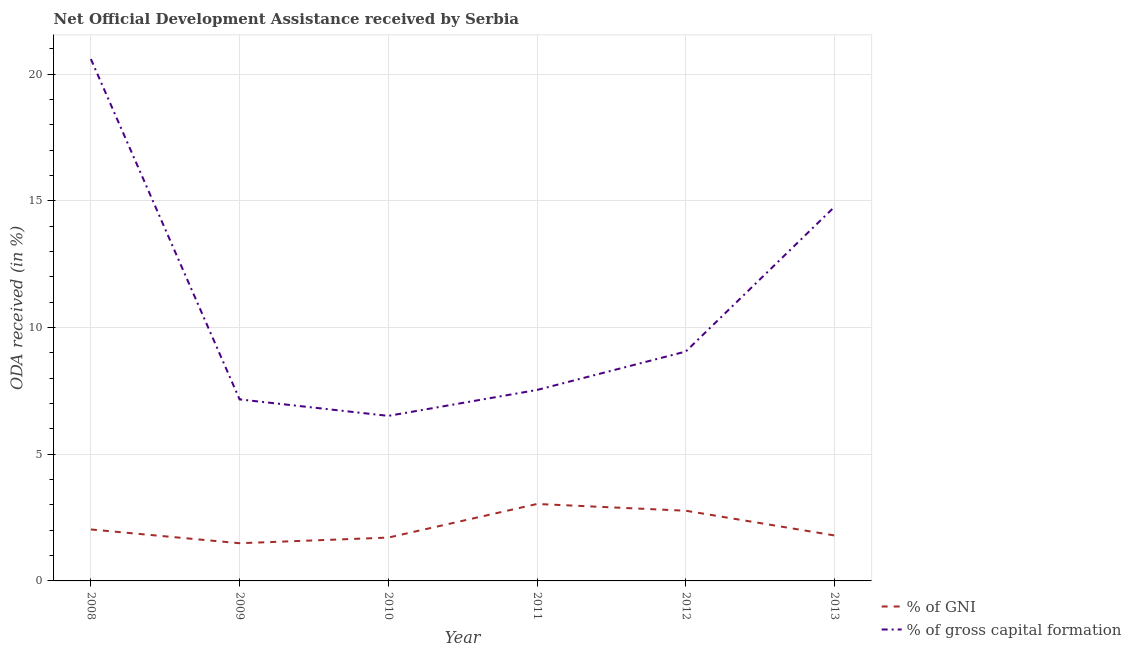How many different coloured lines are there?
Give a very brief answer. 2. What is the oda received as percentage of gross capital formation in 2011?
Ensure brevity in your answer.  7.54. Across all years, what is the maximum oda received as percentage of gni?
Make the answer very short. 3.04. Across all years, what is the minimum oda received as percentage of gni?
Your response must be concise. 1.49. In which year was the oda received as percentage of gni minimum?
Make the answer very short. 2009. What is the total oda received as percentage of gni in the graph?
Ensure brevity in your answer.  12.83. What is the difference between the oda received as percentage of gross capital formation in 2008 and that in 2011?
Provide a succinct answer. 13.06. What is the difference between the oda received as percentage of gross capital formation in 2009 and the oda received as percentage of gni in 2013?
Offer a terse response. 5.37. What is the average oda received as percentage of gross capital formation per year?
Offer a very short reply. 10.94. In the year 2010, what is the difference between the oda received as percentage of gross capital formation and oda received as percentage of gni?
Your response must be concise. 4.8. In how many years, is the oda received as percentage of gni greater than 12 %?
Provide a short and direct response. 0. What is the ratio of the oda received as percentage of gross capital formation in 2008 to that in 2009?
Your answer should be compact. 2.87. What is the difference between the highest and the second highest oda received as percentage of gross capital formation?
Provide a short and direct response. 5.83. What is the difference between the highest and the lowest oda received as percentage of gni?
Your answer should be compact. 1.55. In how many years, is the oda received as percentage of gross capital formation greater than the average oda received as percentage of gross capital formation taken over all years?
Your response must be concise. 2. Is the sum of the oda received as percentage of gross capital formation in 2008 and 2010 greater than the maximum oda received as percentage of gni across all years?
Give a very brief answer. Yes. Is the oda received as percentage of gni strictly greater than the oda received as percentage of gross capital formation over the years?
Offer a terse response. No. Is the oda received as percentage of gross capital formation strictly less than the oda received as percentage of gni over the years?
Keep it short and to the point. No. Are the values on the major ticks of Y-axis written in scientific E-notation?
Provide a succinct answer. No. Where does the legend appear in the graph?
Your response must be concise. Bottom right. How are the legend labels stacked?
Provide a succinct answer. Vertical. What is the title of the graph?
Give a very brief answer. Net Official Development Assistance received by Serbia. Does "Female entrants" appear as one of the legend labels in the graph?
Make the answer very short. No. What is the label or title of the Y-axis?
Keep it short and to the point. ODA received (in %). What is the ODA received (in %) in % of GNI in 2008?
Your answer should be compact. 2.03. What is the ODA received (in %) in % of gross capital formation in 2008?
Your answer should be very brief. 20.6. What is the ODA received (in %) in % of GNI in 2009?
Keep it short and to the point. 1.49. What is the ODA received (in %) of % of gross capital formation in 2009?
Your answer should be very brief. 7.16. What is the ODA received (in %) in % of GNI in 2010?
Make the answer very short. 1.71. What is the ODA received (in %) in % of gross capital formation in 2010?
Ensure brevity in your answer.  6.51. What is the ODA received (in %) in % of GNI in 2011?
Keep it short and to the point. 3.04. What is the ODA received (in %) in % of gross capital formation in 2011?
Give a very brief answer. 7.54. What is the ODA received (in %) in % of GNI in 2012?
Your answer should be very brief. 2.77. What is the ODA received (in %) in % of gross capital formation in 2012?
Make the answer very short. 9.05. What is the ODA received (in %) in % of GNI in 2013?
Give a very brief answer. 1.79. What is the ODA received (in %) of % of gross capital formation in 2013?
Provide a succinct answer. 14.77. Across all years, what is the maximum ODA received (in %) of % of GNI?
Your answer should be compact. 3.04. Across all years, what is the maximum ODA received (in %) of % of gross capital formation?
Your answer should be compact. 20.6. Across all years, what is the minimum ODA received (in %) in % of GNI?
Give a very brief answer. 1.49. Across all years, what is the minimum ODA received (in %) of % of gross capital formation?
Provide a succinct answer. 6.51. What is the total ODA received (in %) in % of GNI in the graph?
Your answer should be compact. 12.83. What is the total ODA received (in %) in % of gross capital formation in the graph?
Keep it short and to the point. 65.63. What is the difference between the ODA received (in %) in % of GNI in 2008 and that in 2009?
Ensure brevity in your answer.  0.54. What is the difference between the ODA received (in %) of % of gross capital formation in 2008 and that in 2009?
Ensure brevity in your answer.  13.43. What is the difference between the ODA received (in %) in % of GNI in 2008 and that in 2010?
Make the answer very short. 0.32. What is the difference between the ODA received (in %) in % of gross capital formation in 2008 and that in 2010?
Offer a terse response. 14.08. What is the difference between the ODA received (in %) of % of GNI in 2008 and that in 2011?
Your response must be concise. -1.01. What is the difference between the ODA received (in %) of % of gross capital formation in 2008 and that in 2011?
Offer a very short reply. 13.06. What is the difference between the ODA received (in %) in % of GNI in 2008 and that in 2012?
Give a very brief answer. -0.74. What is the difference between the ODA received (in %) in % of gross capital formation in 2008 and that in 2012?
Make the answer very short. 11.54. What is the difference between the ODA received (in %) in % of GNI in 2008 and that in 2013?
Provide a short and direct response. 0.24. What is the difference between the ODA received (in %) in % of gross capital formation in 2008 and that in 2013?
Offer a terse response. 5.83. What is the difference between the ODA received (in %) of % of GNI in 2009 and that in 2010?
Keep it short and to the point. -0.22. What is the difference between the ODA received (in %) in % of gross capital formation in 2009 and that in 2010?
Your response must be concise. 0.65. What is the difference between the ODA received (in %) of % of GNI in 2009 and that in 2011?
Make the answer very short. -1.55. What is the difference between the ODA received (in %) in % of gross capital formation in 2009 and that in 2011?
Your response must be concise. -0.37. What is the difference between the ODA received (in %) in % of GNI in 2009 and that in 2012?
Make the answer very short. -1.28. What is the difference between the ODA received (in %) of % of gross capital formation in 2009 and that in 2012?
Provide a succinct answer. -1.89. What is the difference between the ODA received (in %) in % of GNI in 2009 and that in 2013?
Keep it short and to the point. -0.31. What is the difference between the ODA received (in %) in % of gross capital formation in 2009 and that in 2013?
Give a very brief answer. -7.6. What is the difference between the ODA received (in %) in % of GNI in 2010 and that in 2011?
Offer a very short reply. -1.33. What is the difference between the ODA received (in %) of % of gross capital formation in 2010 and that in 2011?
Give a very brief answer. -1.02. What is the difference between the ODA received (in %) of % of GNI in 2010 and that in 2012?
Provide a short and direct response. -1.06. What is the difference between the ODA received (in %) in % of gross capital formation in 2010 and that in 2012?
Give a very brief answer. -2.54. What is the difference between the ODA received (in %) in % of GNI in 2010 and that in 2013?
Give a very brief answer. -0.08. What is the difference between the ODA received (in %) in % of gross capital formation in 2010 and that in 2013?
Your answer should be very brief. -8.25. What is the difference between the ODA received (in %) in % of GNI in 2011 and that in 2012?
Give a very brief answer. 0.27. What is the difference between the ODA received (in %) of % of gross capital formation in 2011 and that in 2012?
Offer a very short reply. -1.52. What is the difference between the ODA received (in %) of % of GNI in 2011 and that in 2013?
Provide a short and direct response. 1.24. What is the difference between the ODA received (in %) in % of gross capital formation in 2011 and that in 2013?
Your answer should be compact. -7.23. What is the difference between the ODA received (in %) of % of GNI in 2012 and that in 2013?
Provide a succinct answer. 0.98. What is the difference between the ODA received (in %) in % of gross capital formation in 2012 and that in 2013?
Your answer should be very brief. -5.71. What is the difference between the ODA received (in %) in % of GNI in 2008 and the ODA received (in %) in % of gross capital formation in 2009?
Keep it short and to the point. -5.13. What is the difference between the ODA received (in %) in % of GNI in 2008 and the ODA received (in %) in % of gross capital formation in 2010?
Your answer should be very brief. -4.48. What is the difference between the ODA received (in %) of % of GNI in 2008 and the ODA received (in %) of % of gross capital formation in 2011?
Ensure brevity in your answer.  -5.51. What is the difference between the ODA received (in %) in % of GNI in 2008 and the ODA received (in %) in % of gross capital formation in 2012?
Give a very brief answer. -7.02. What is the difference between the ODA received (in %) in % of GNI in 2008 and the ODA received (in %) in % of gross capital formation in 2013?
Make the answer very short. -12.73. What is the difference between the ODA received (in %) in % of GNI in 2009 and the ODA received (in %) in % of gross capital formation in 2010?
Offer a very short reply. -5.03. What is the difference between the ODA received (in %) of % of GNI in 2009 and the ODA received (in %) of % of gross capital formation in 2011?
Provide a succinct answer. -6.05. What is the difference between the ODA received (in %) in % of GNI in 2009 and the ODA received (in %) in % of gross capital formation in 2012?
Make the answer very short. -7.57. What is the difference between the ODA received (in %) of % of GNI in 2009 and the ODA received (in %) of % of gross capital formation in 2013?
Make the answer very short. -13.28. What is the difference between the ODA received (in %) in % of GNI in 2010 and the ODA received (in %) in % of gross capital formation in 2011?
Provide a succinct answer. -5.83. What is the difference between the ODA received (in %) in % of GNI in 2010 and the ODA received (in %) in % of gross capital formation in 2012?
Keep it short and to the point. -7.34. What is the difference between the ODA received (in %) in % of GNI in 2010 and the ODA received (in %) in % of gross capital formation in 2013?
Keep it short and to the point. -13.05. What is the difference between the ODA received (in %) in % of GNI in 2011 and the ODA received (in %) in % of gross capital formation in 2012?
Your answer should be compact. -6.02. What is the difference between the ODA received (in %) of % of GNI in 2011 and the ODA received (in %) of % of gross capital formation in 2013?
Offer a very short reply. -11.73. What is the difference between the ODA received (in %) of % of GNI in 2012 and the ODA received (in %) of % of gross capital formation in 2013?
Offer a terse response. -11.99. What is the average ODA received (in %) in % of GNI per year?
Give a very brief answer. 2.14. What is the average ODA received (in %) of % of gross capital formation per year?
Ensure brevity in your answer.  10.94. In the year 2008, what is the difference between the ODA received (in %) in % of GNI and ODA received (in %) in % of gross capital formation?
Your answer should be very brief. -18.57. In the year 2009, what is the difference between the ODA received (in %) of % of GNI and ODA received (in %) of % of gross capital formation?
Your answer should be compact. -5.68. In the year 2010, what is the difference between the ODA received (in %) in % of GNI and ODA received (in %) in % of gross capital formation?
Provide a short and direct response. -4.8. In the year 2011, what is the difference between the ODA received (in %) in % of GNI and ODA received (in %) in % of gross capital formation?
Offer a terse response. -4.5. In the year 2012, what is the difference between the ODA received (in %) of % of GNI and ODA received (in %) of % of gross capital formation?
Offer a terse response. -6.28. In the year 2013, what is the difference between the ODA received (in %) of % of GNI and ODA received (in %) of % of gross capital formation?
Make the answer very short. -12.97. What is the ratio of the ODA received (in %) in % of GNI in 2008 to that in 2009?
Your answer should be compact. 1.37. What is the ratio of the ODA received (in %) in % of gross capital formation in 2008 to that in 2009?
Offer a very short reply. 2.87. What is the ratio of the ODA received (in %) of % of GNI in 2008 to that in 2010?
Keep it short and to the point. 1.19. What is the ratio of the ODA received (in %) in % of gross capital formation in 2008 to that in 2010?
Offer a terse response. 3.16. What is the ratio of the ODA received (in %) of % of GNI in 2008 to that in 2011?
Your answer should be compact. 0.67. What is the ratio of the ODA received (in %) of % of gross capital formation in 2008 to that in 2011?
Provide a succinct answer. 2.73. What is the ratio of the ODA received (in %) of % of GNI in 2008 to that in 2012?
Ensure brevity in your answer.  0.73. What is the ratio of the ODA received (in %) of % of gross capital formation in 2008 to that in 2012?
Offer a terse response. 2.27. What is the ratio of the ODA received (in %) of % of GNI in 2008 to that in 2013?
Make the answer very short. 1.13. What is the ratio of the ODA received (in %) in % of gross capital formation in 2008 to that in 2013?
Make the answer very short. 1.4. What is the ratio of the ODA received (in %) of % of GNI in 2009 to that in 2010?
Keep it short and to the point. 0.87. What is the ratio of the ODA received (in %) of % of gross capital formation in 2009 to that in 2010?
Offer a terse response. 1.1. What is the ratio of the ODA received (in %) of % of GNI in 2009 to that in 2011?
Offer a terse response. 0.49. What is the ratio of the ODA received (in %) of % of gross capital formation in 2009 to that in 2011?
Make the answer very short. 0.95. What is the ratio of the ODA received (in %) of % of GNI in 2009 to that in 2012?
Make the answer very short. 0.54. What is the ratio of the ODA received (in %) in % of gross capital formation in 2009 to that in 2012?
Your response must be concise. 0.79. What is the ratio of the ODA received (in %) of % of GNI in 2009 to that in 2013?
Provide a short and direct response. 0.83. What is the ratio of the ODA received (in %) of % of gross capital formation in 2009 to that in 2013?
Offer a terse response. 0.49. What is the ratio of the ODA received (in %) of % of GNI in 2010 to that in 2011?
Make the answer very short. 0.56. What is the ratio of the ODA received (in %) in % of gross capital formation in 2010 to that in 2011?
Your response must be concise. 0.86. What is the ratio of the ODA received (in %) in % of GNI in 2010 to that in 2012?
Make the answer very short. 0.62. What is the ratio of the ODA received (in %) of % of gross capital formation in 2010 to that in 2012?
Keep it short and to the point. 0.72. What is the ratio of the ODA received (in %) in % of GNI in 2010 to that in 2013?
Offer a very short reply. 0.95. What is the ratio of the ODA received (in %) in % of gross capital formation in 2010 to that in 2013?
Ensure brevity in your answer.  0.44. What is the ratio of the ODA received (in %) in % of GNI in 2011 to that in 2012?
Keep it short and to the point. 1.1. What is the ratio of the ODA received (in %) of % of gross capital formation in 2011 to that in 2012?
Offer a very short reply. 0.83. What is the ratio of the ODA received (in %) in % of GNI in 2011 to that in 2013?
Your answer should be very brief. 1.69. What is the ratio of the ODA received (in %) of % of gross capital formation in 2011 to that in 2013?
Provide a short and direct response. 0.51. What is the ratio of the ODA received (in %) in % of GNI in 2012 to that in 2013?
Give a very brief answer. 1.54. What is the ratio of the ODA received (in %) in % of gross capital formation in 2012 to that in 2013?
Offer a terse response. 0.61. What is the difference between the highest and the second highest ODA received (in %) of % of GNI?
Keep it short and to the point. 0.27. What is the difference between the highest and the second highest ODA received (in %) in % of gross capital formation?
Provide a short and direct response. 5.83. What is the difference between the highest and the lowest ODA received (in %) of % of GNI?
Offer a terse response. 1.55. What is the difference between the highest and the lowest ODA received (in %) of % of gross capital formation?
Offer a very short reply. 14.08. 